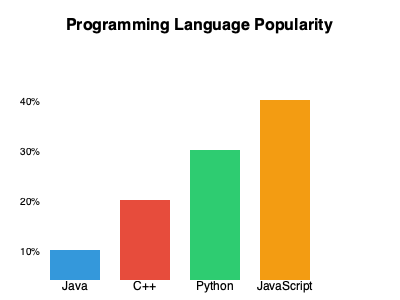As an enthusiastic programmer, you're analyzing a bar chart showing the popularity of different programming languages. Which language is the most popular according to the chart, and by approximately what percentage? To answer this question, we need to follow these steps:

1. Identify the languages represented in the chart:
   - Java
   - C++
   - Python
   - JavaScript

2. Compare the heights of the bars:
   - Java: Shortest bar, about 10% popularity
   - C++: Second shortest, about 20% popularity
   - Python: Second tallest, about 30% popularity
   - JavaScript: Tallest bar, about 40% popularity

3. Determine the most popular language:
   - JavaScript has the tallest bar, indicating it's the most popular language in this chart.

4. Estimate the percentage for JavaScript:
   - The JavaScript bar reaches the 40% mark on the y-axis.

Therefore, JavaScript is the most popular language according to this chart, with approximately 40% popularity.
Answer: JavaScript, 40% 